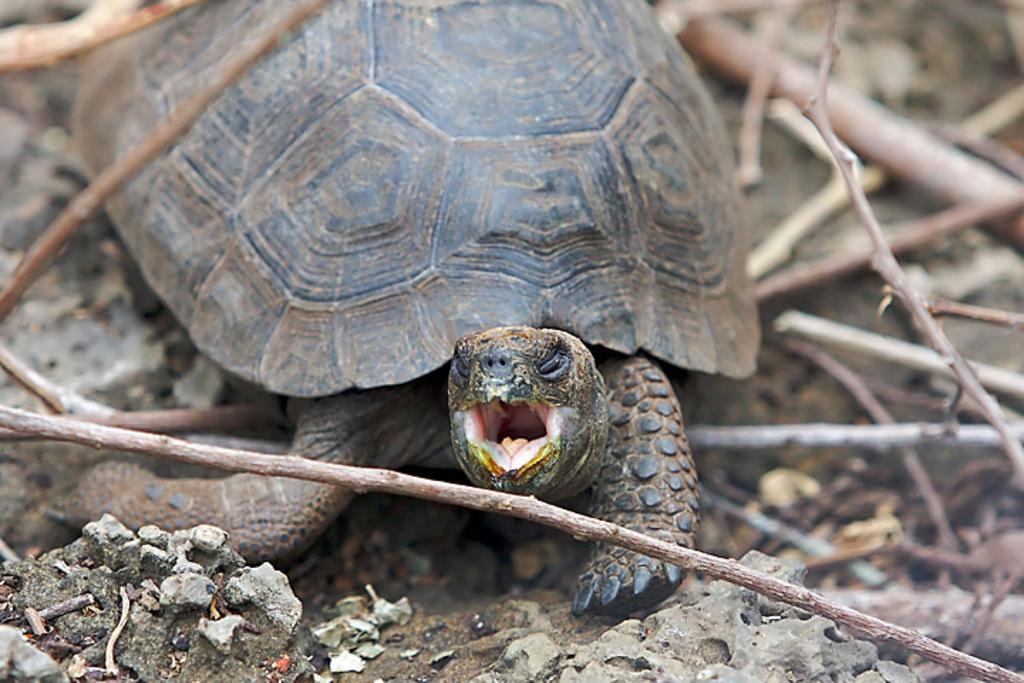How would you summarize this image in a sentence or two? In this image, we can see a tortoise. We can see the ground with some objects and a few wooden sticks. 